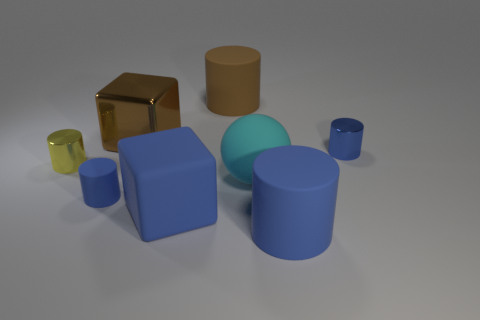What material is the tiny yellow object?
Provide a short and direct response. Metal. The large rubber block has what color?
Your response must be concise. Blue. What color is the small cylinder that is both left of the big cyan rubber thing and right of the small yellow object?
Provide a succinct answer. Blue. Is there anything else that is the same material as the blue block?
Offer a very short reply. Yes. Is the material of the large cyan sphere the same as the blue object that is behind the small yellow metallic cylinder?
Your answer should be compact. No. There is a cube behind the small blue object in front of the small blue metallic cylinder; what is its size?
Your answer should be compact. Large. Are there any other things that are the same color as the tiny matte cylinder?
Provide a short and direct response. Yes. Is the material of the tiny object right of the blue block the same as the big cyan ball to the right of the blue matte cube?
Make the answer very short. No. There is a large thing that is both left of the brown cylinder and in front of the brown shiny object; what is its material?
Your response must be concise. Rubber. Does the yellow metallic thing have the same shape as the metallic thing on the right side of the big cyan sphere?
Offer a very short reply. Yes. 